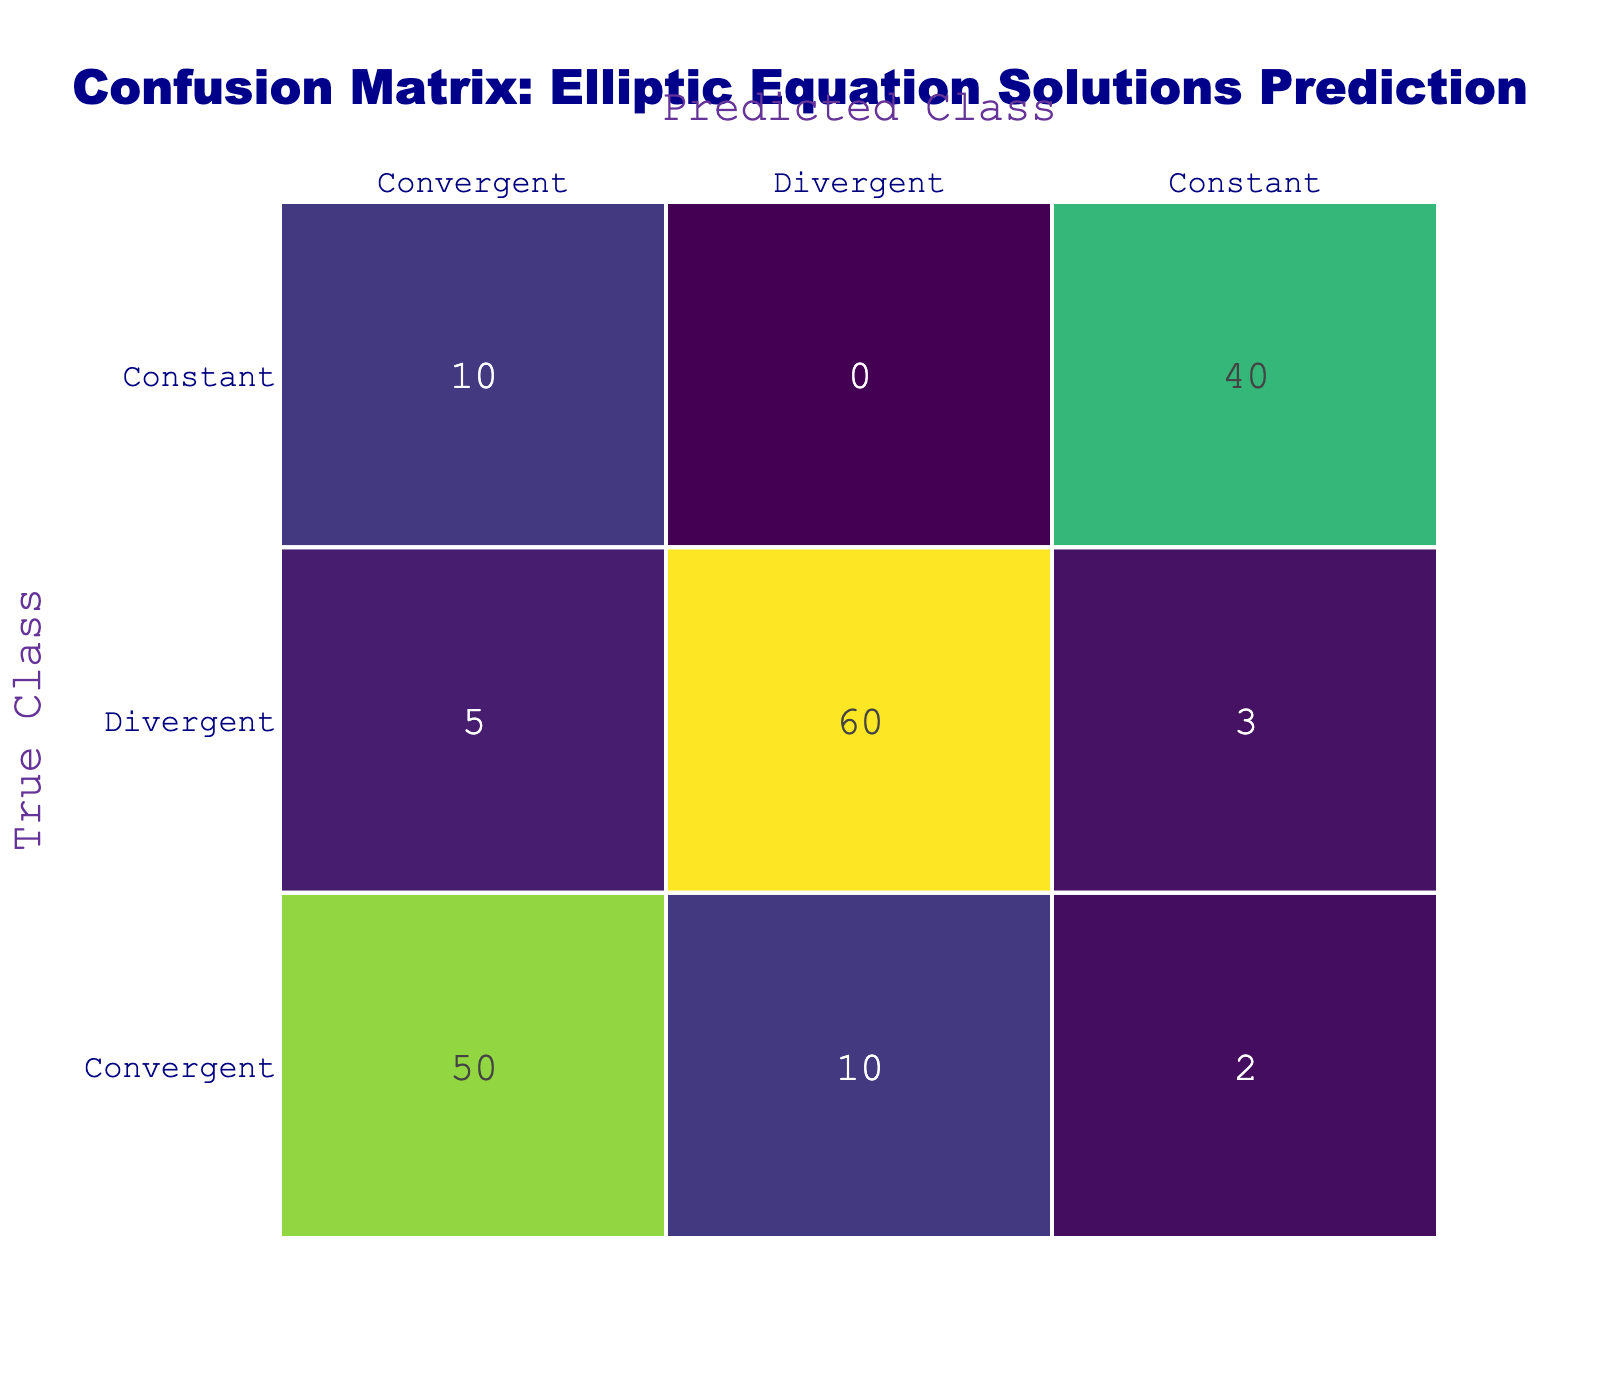What is the count of true positives for the "Convergent" class? The count for true positives in the "Convergent" class corresponds to the intersection of "Convergent" in both predicted and true classes from the matrix, which shows a value of 50.
Answer: 50 What is the total number of predictions made for the "Divergent" class? To find the total predictions made for the "Divergent" class, we sum the values in the "Divergent" column: 5 (True Divergent predicted as Divergent) + 60 (True Divergent predicted as Divergent) + 10 (True Convergent predicted as Divergent) + 3 (True Constant predicted as Divergent) = 78.
Answer: 78 Is the "Constant" class classified more frequently as "Divergent" or "Constant"? In the matrix, "Constant" appears in two categories: 3 times as "Divergent" and 40 times as "Constant." Since 40 is greater than 3, the "Constant" class is classified more frequently as "Constant."
Answer: Yes What is the percentage of true convergent cases predicted accurately? The true positive count for "Convergent" is 50, while the total instances for "Convergent" (true and false predictions) is 50 + 10 + 2 = 62. Therefore, the percentage is (50/62) * 100, which is approximately 80.65%.
Answer: 80.65% What is the sum of all classes predicted as "Convergent"? To find the total predicted as "Convergent," we sum the values in the "Convergent" column: 50 (True Convergent) + 10 (True Constant) + 2 (True Constant) = 62.
Answer: 62 Which class has the highest number of false positives? From the false positive values (Divergent predicted as Convergent), the only false positive case is 10, while all other classes don't have false positives exceeding this number. Therefore, "Divergent" has the highest number of false positives.
Answer: Divergent What is the difference between the true positive count of "Divergent" and "Constant"? The true positive count for "Divergent" is 60, while for "Constant," it is 40. The difference is calculated as 60 - 40 = 20.
Answer: 20 What proportion of "Constant" instances were predicted as "Constant"? The "Constant" instances that were correctly predicted as "Constant" are 40, and the total instances of "Constant" (true) is 40 + 3 + 2 = 45. The proportion is calculated as 40 / 45, which simplifies to about 0.889 or 88.89%.
Answer: 88.89% How many total predictions were made for the "Divergent" class, including true positives? The total predictions made for "Divergent" are obtained by adding true positives and false positives: 60 (True True) + 10 (False True) = 70.
Answer: 70 